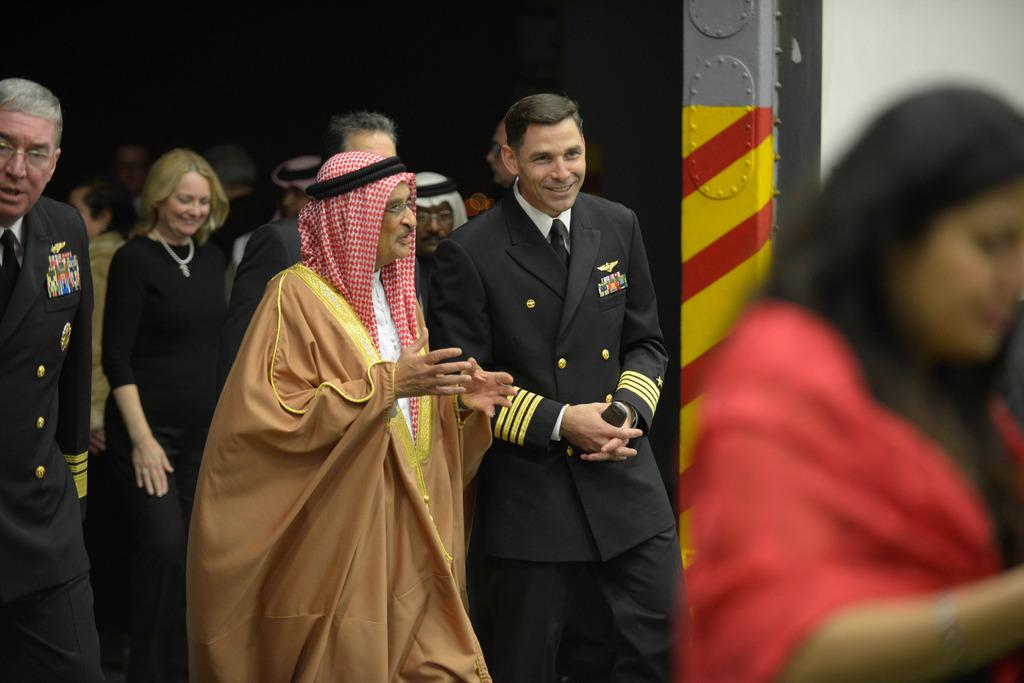What can be seen in the image involving people? There are people standing in the image. Where are the people standing? The people are standing on the ground. What other object is present in the image? There is an iron bar in the image. What type of cork can be seen floating in the sea in the image? There is no sea or cork present in the image; it features people standing on the ground and an iron bar. What decisions is the committee making in the image? There is no committee or decision-making process depicted in the image. 